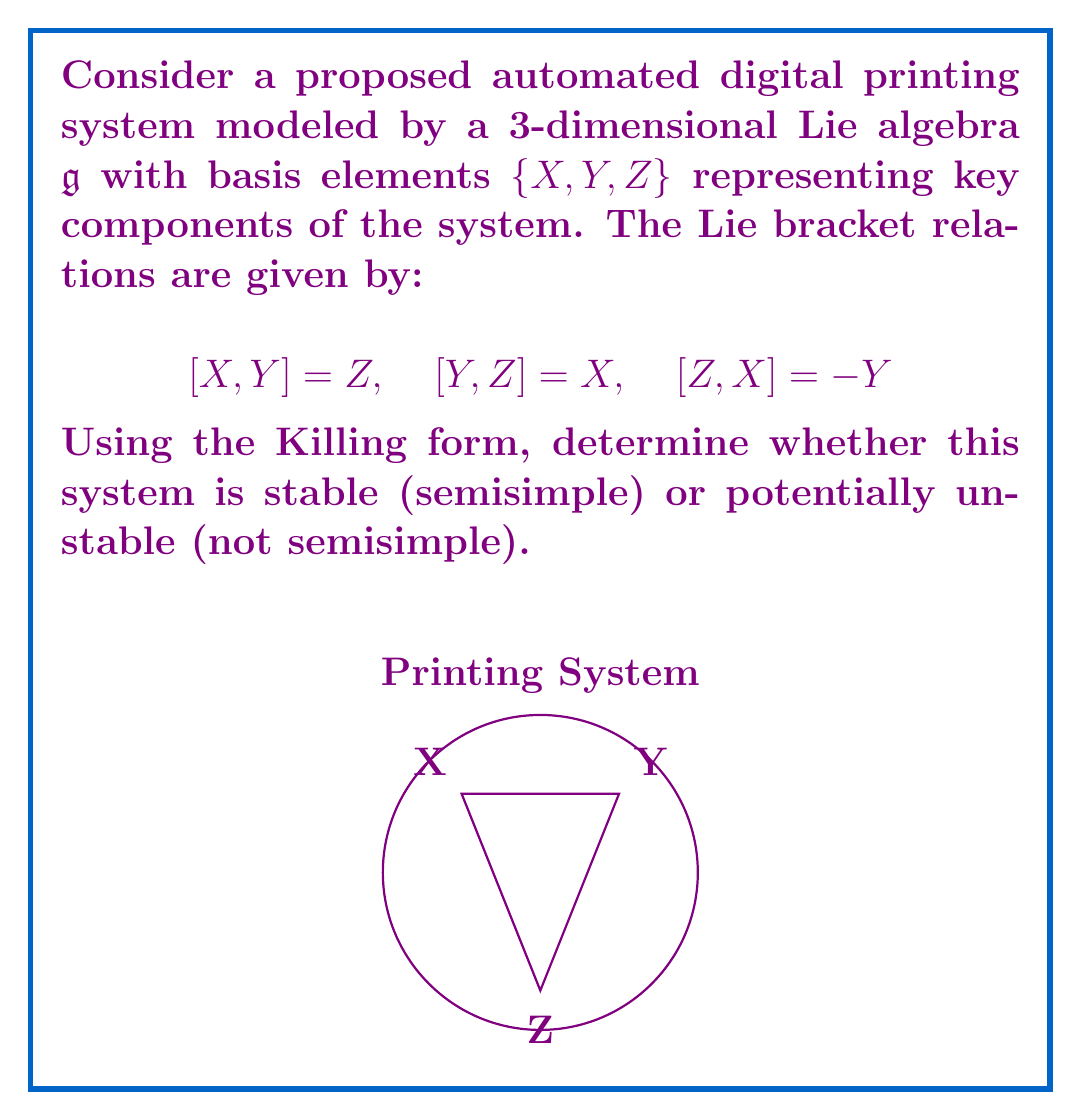Can you solve this math problem? To analyze the stability of the system using the Killing form, we follow these steps:

1) First, we need to calculate the Killing form $B(X, Y) = \text{tr}(\text{ad}_X \circ \text{ad}_Y)$ for all pairs of basis elements.

2) For each basis element, we calculate its adjoint representation matrix:

   $\text{ad}_X = \begin{pmatrix} 0 & 0 & -1 \\ 0 & 0 & 0 \\ 0 & 1 & 0 \end{pmatrix}$
   
   $\text{ad}_Y = \begin{pmatrix} 0 & 0 & 0 \\ 0 & 0 & 1 \\ 1 & 0 & 0 \end{pmatrix}$
   
   $\text{ad}_Z = \begin{pmatrix} 0 & -1 & 0 \\ 1 & 0 & 0 \\ 0 & 0 & 0 \end{pmatrix}$

3) Now we calculate the Killing form for each pair:

   $B(X,X) = \text{tr}(\text{ad}_X \circ \text{ad}_X) = -2$
   $B(Y,Y) = \text{tr}(\text{ad}_Y \circ \text{ad}_Y) = -2$
   $B(Z,Z) = \text{tr}(\text{ad}_Z \circ \text{ad}_Z) = -2$
   $B(X,Y) = B(Y,X) = \text{tr}(\text{ad}_X \circ \text{ad}_Y) = 0$
   $B(X,Z) = B(Z,X) = \text{tr}(\text{ad}_X \circ \text{ad}_Z) = 0$
   $B(Y,Z) = B(Z,Y) = \text{tr}(\text{ad}_Y \circ \text{ad}_Z) = 0$

4) The Killing form matrix is:

   $B = \begin{pmatrix} -2 & 0 & 0 \\ 0 & -2 & 0 \\ 0 & 0 & -2 \end{pmatrix}$

5) A Lie algebra is semisimple if and only if its Killing form is non-degenerate (i.e., has non-zero determinant).

6) The determinant of B is $\det(B) = (-2)^3 = -8 \neq 0$

Therefore, the Killing form is non-degenerate, implying that the Lie algebra is semisimple.
Answer: The system is stable (semisimple). 